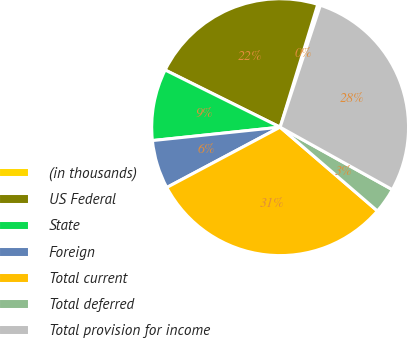Convert chart to OTSL. <chart><loc_0><loc_0><loc_500><loc_500><pie_chart><fcel>(in thousands)<fcel>US Federal<fcel>State<fcel>Foreign<fcel>Total current<fcel>Total deferred<fcel>Total provision for income<nl><fcel>0.34%<fcel>22.39%<fcel>9.01%<fcel>6.12%<fcel>30.9%<fcel>3.23%<fcel>28.01%<nl></chart> 